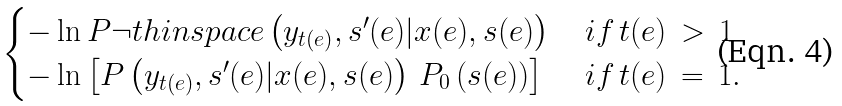Convert formula to latex. <formula><loc_0><loc_0><loc_500><loc_500>\begin{cases} - \ln P \neg t h i n s p a c e \left ( y _ { t ( e ) } , s ^ { \prime } ( e ) | x ( e ) , s ( e ) \right ) \, & i f \, t ( e ) \, > \, 1 \\ - \ln \left [ P \left ( y _ { t ( e ) } , s ^ { \prime } ( e ) | x ( e ) , s ( e ) \right ) \, P _ { 0 } \left ( s ( e ) \right ) \right ] \, & i f \, t ( e ) \, = \, 1 . \end{cases}</formula> 